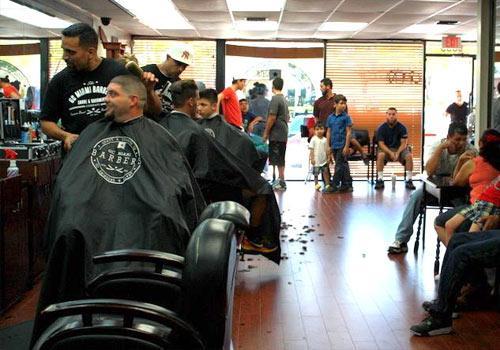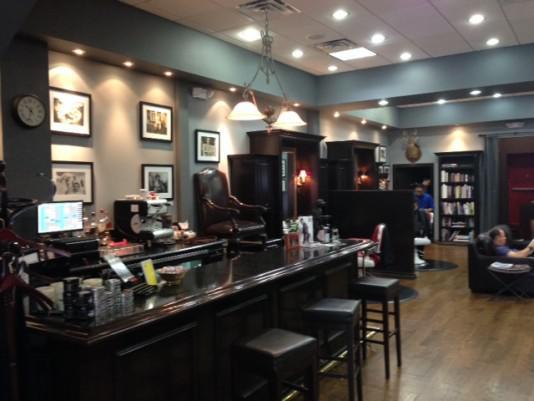The first image is the image on the left, the second image is the image on the right. Considering the images on both sides, is "The left image features a row of male customers sitting and wearing black smocks, with someone standing behind them." valid? Answer yes or no. Yes. The first image is the image on the left, the second image is the image on the right. Assess this claim about the two images: "In at least one image there are at least three men with black hair getting there hair cut.". Correct or not? Answer yes or no. Yes. 